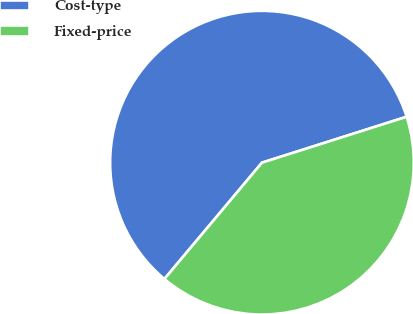Convert chart to OTSL. <chart><loc_0><loc_0><loc_500><loc_500><pie_chart><fcel>Cost-type<fcel>Fixed-price<nl><fcel>59.0%<fcel>41.0%<nl></chart> 